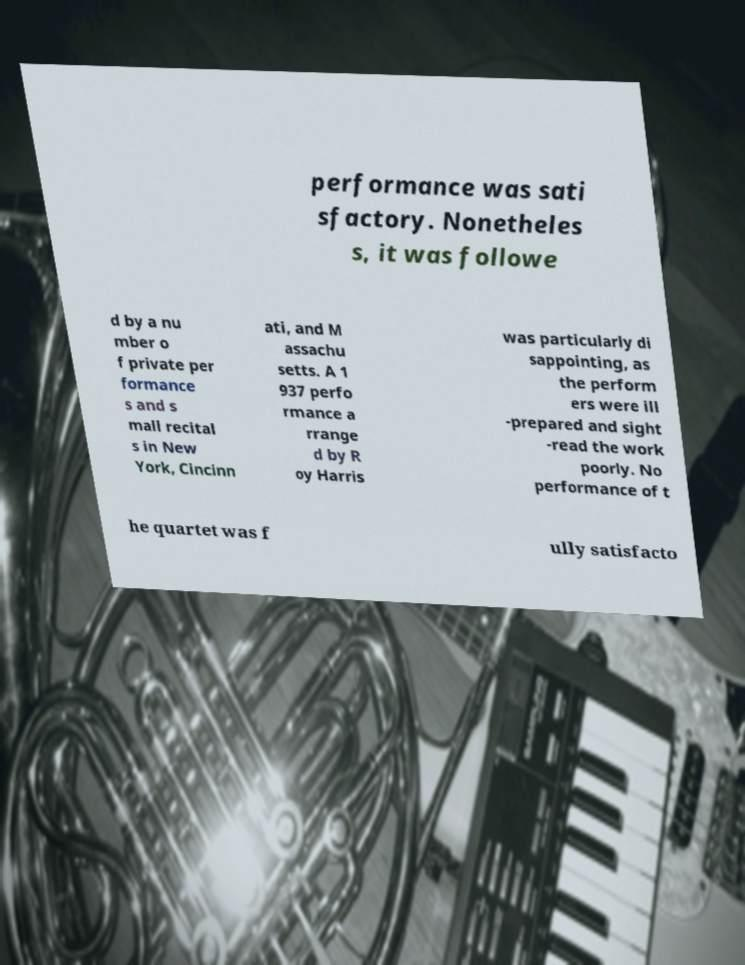For documentation purposes, I need the text within this image transcribed. Could you provide that? performance was sati sfactory. Nonetheles s, it was followe d by a nu mber o f private per formance s and s mall recital s in New York, Cincinn ati, and M assachu setts. A 1 937 perfo rmance a rrange d by R oy Harris was particularly di sappointing, as the perform ers were ill -prepared and sight -read the work poorly. No performance of t he quartet was f ully satisfacto 